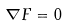Convert formula to latex. <formula><loc_0><loc_0><loc_500><loc_500>\nabla F = 0</formula> 